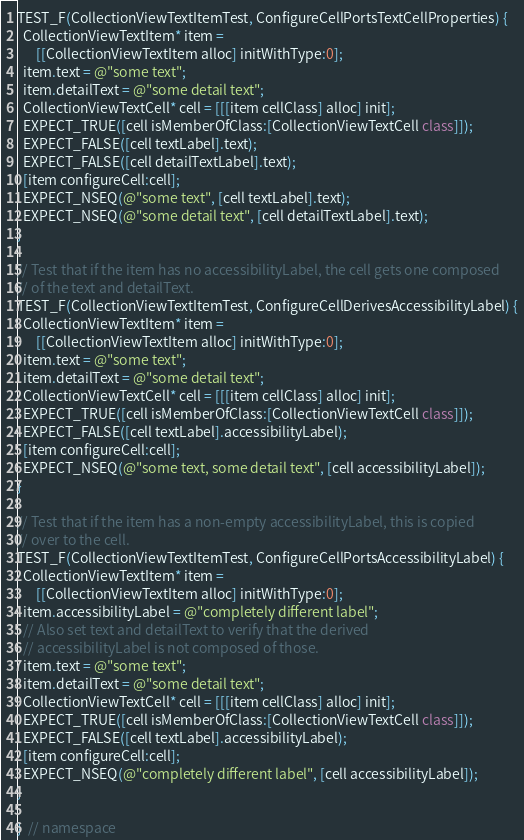<code> <loc_0><loc_0><loc_500><loc_500><_ObjectiveC_>TEST_F(CollectionViewTextItemTest, ConfigureCellPortsTextCellProperties) {
  CollectionViewTextItem* item =
      [[CollectionViewTextItem alloc] initWithType:0];
  item.text = @"some text";
  item.detailText = @"some detail text";
  CollectionViewTextCell* cell = [[[item cellClass] alloc] init];
  EXPECT_TRUE([cell isMemberOfClass:[CollectionViewTextCell class]]);
  EXPECT_FALSE([cell textLabel].text);
  EXPECT_FALSE([cell detailTextLabel].text);
  [item configureCell:cell];
  EXPECT_NSEQ(@"some text", [cell textLabel].text);
  EXPECT_NSEQ(@"some detail text", [cell detailTextLabel].text);
}

// Test that if the item has no accessibilityLabel, the cell gets one composed
// of the text and detailText.
TEST_F(CollectionViewTextItemTest, ConfigureCellDerivesAccessibilityLabel) {
  CollectionViewTextItem* item =
      [[CollectionViewTextItem alloc] initWithType:0];
  item.text = @"some text";
  item.detailText = @"some detail text";
  CollectionViewTextCell* cell = [[[item cellClass] alloc] init];
  EXPECT_TRUE([cell isMemberOfClass:[CollectionViewTextCell class]]);
  EXPECT_FALSE([cell textLabel].accessibilityLabel);
  [item configureCell:cell];
  EXPECT_NSEQ(@"some text, some detail text", [cell accessibilityLabel]);
}

// Test that if the item has a non-empty accessibilityLabel, this is copied
// over to the cell.
TEST_F(CollectionViewTextItemTest, ConfigureCellPortsAccessibilityLabel) {
  CollectionViewTextItem* item =
      [[CollectionViewTextItem alloc] initWithType:0];
  item.accessibilityLabel = @"completely different label";
  // Also set text and detailText to verify that the derived
  // accessibilityLabel is not composed of those.
  item.text = @"some text";
  item.detailText = @"some detail text";
  CollectionViewTextCell* cell = [[[item cellClass] alloc] init];
  EXPECT_TRUE([cell isMemberOfClass:[CollectionViewTextCell class]]);
  EXPECT_FALSE([cell textLabel].accessibilityLabel);
  [item configureCell:cell];
  EXPECT_NSEQ(@"completely different label", [cell accessibilityLabel]);
}

}  // namespace
</code> 